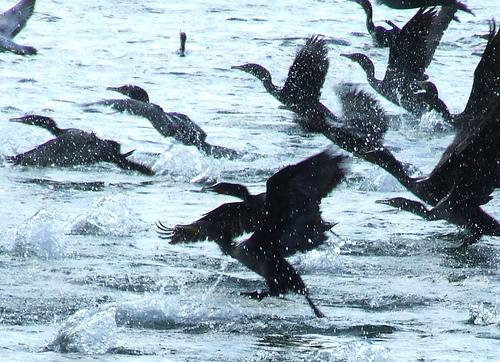What is in the water?
Quick response, please. Birds. What are the birds doing?
Concise answer only. Flying. How many are there?
Give a very brief answer. 10. 